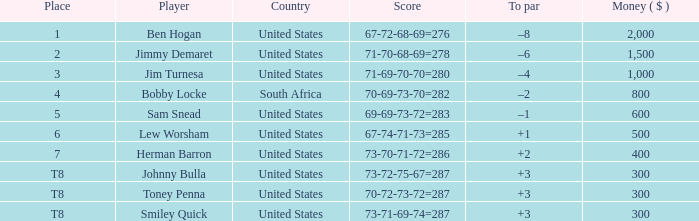What is the Score of the game of the Player in Place 4? 70-69-73-70=282. 